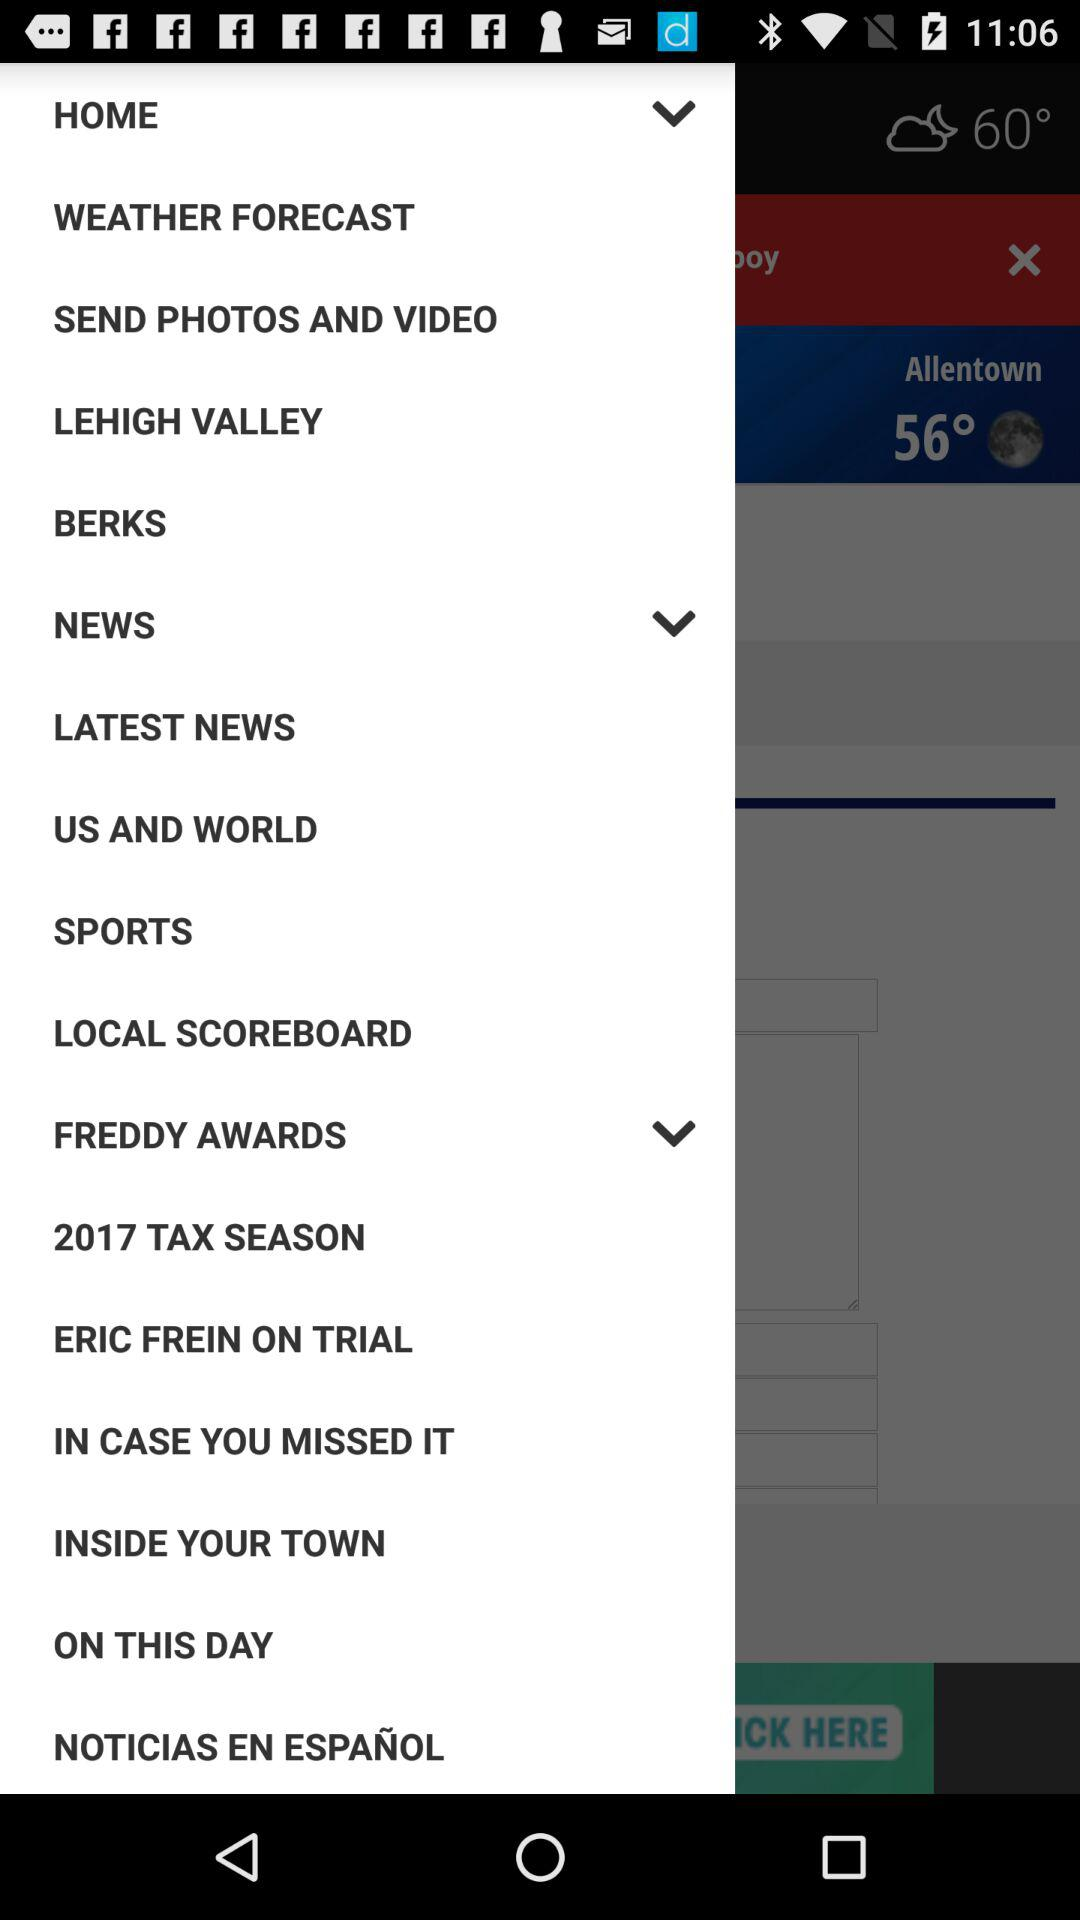What is the temperature? The temperatures are 60° and 56°. 